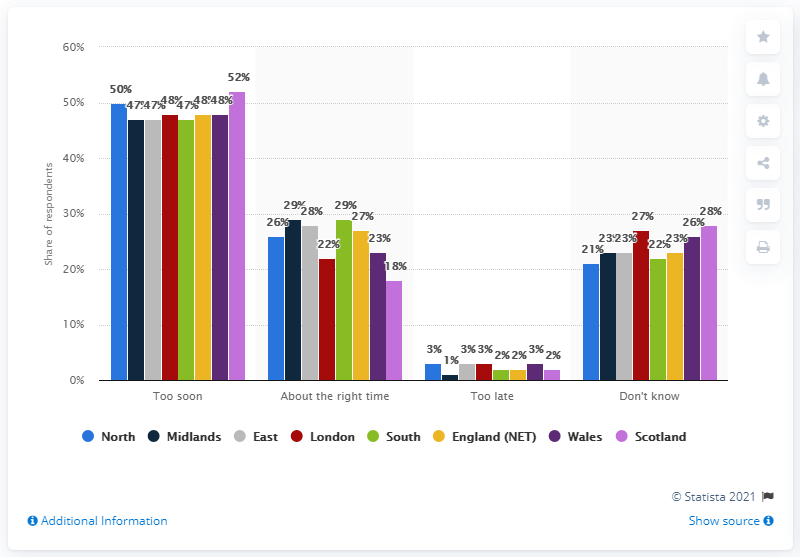Indicate a few pertinent items in this graphic. According to the survey results in England, 29% of respondents believed that June 17 was the right time for the Premier League to return. 